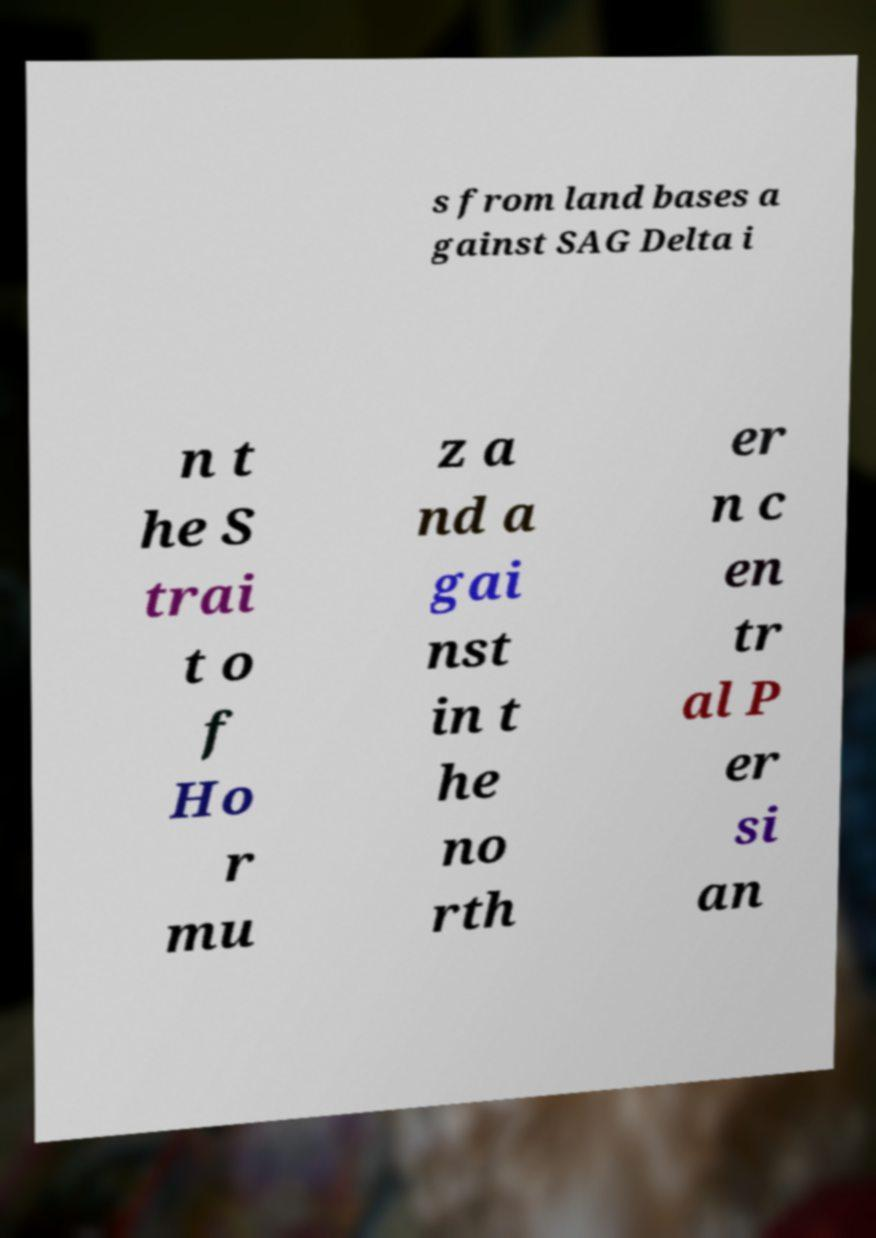There's text embedded in this image that I need extracted. Can you transcribe it verbatim? s from land bases a gainst SAG Delta i n t he S trai t o f Ho r mu z a nd a gai nst in t he no rth er n c en tr al P er si an 